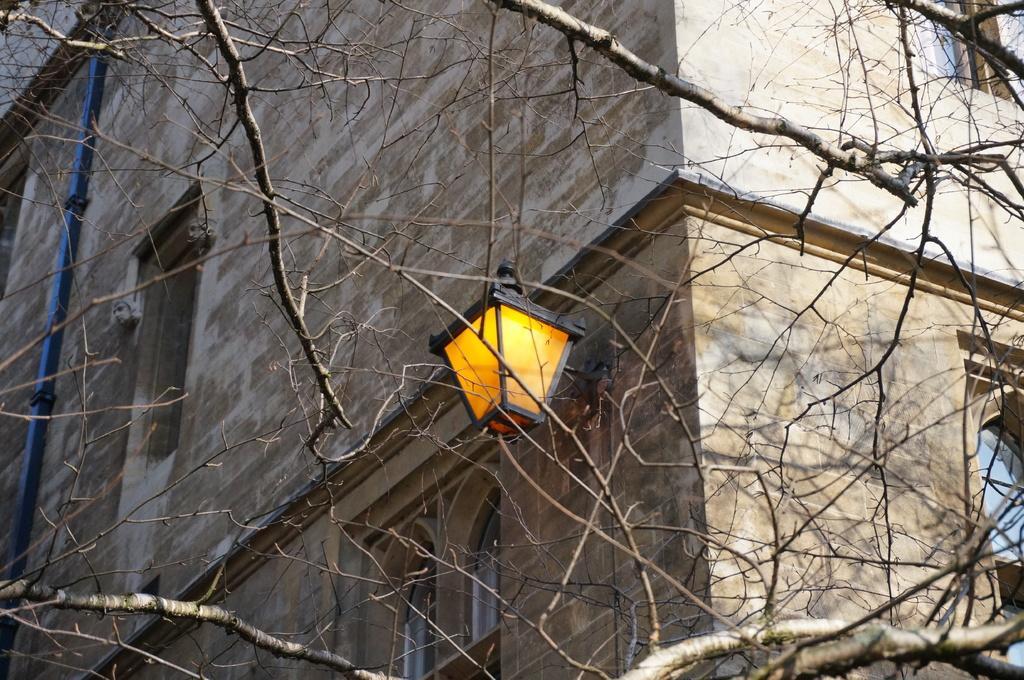In one or two sentences, can you explain what this image depicts? In the picture we can see a part of a dried tree from it we can see a part of the building with windows and glasses to it and near to it we can see a lamp and beside it we can see a pole. 